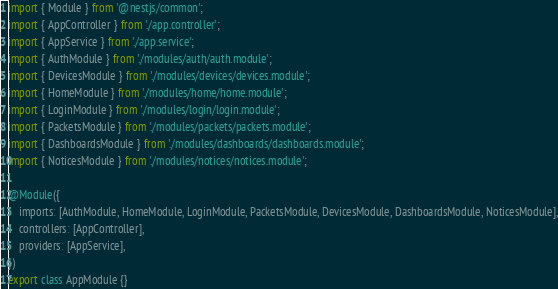<code> <loc_0><loc_0><loc_500><loc_500><_TypeScript_>import { Module } from '@nestjs/common';
import { AppController } from './app.controller';
import { AppService } from './app.service';
import { AuthModule } from './modules/auth/auth.module';
import { DevicesModule } from './modules/devices/devices.module';
import { HomeModule } from './modules/home/home.module';
import { LoginModule } from './modules/login/login.module';
import { PacketsModule } from './modules/packets/packets.module';
import { DashboardsModule } from './modules/dashboards/dashboards.module';
import { NoticesModule } from './modules/notices/notices.module';

@Module({
    imports: [AuthModule, HomeModule, LoginModule, PacketsModule, DevicesModule, DashboardsModule, NoticesModule],
    controllers: [AppController],
    providers: [AppService],
})
export class AppModule {}
</code> 